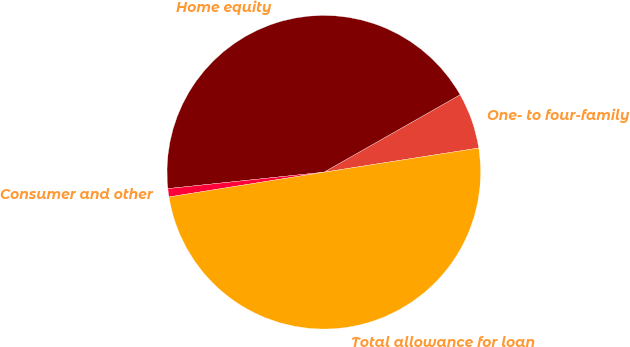Convert chart. <chart><loc_0><loc_0><loc_500><loc_500><pie_chart><fcel>One- to four-family<fcel>Home equity<fcel>Consumer and other<fcel>Total allowance for loan<nl><fcel>5.76%<fcel>43.44%<fcel>0.85%<fcel>49.95%<nl></chart> 